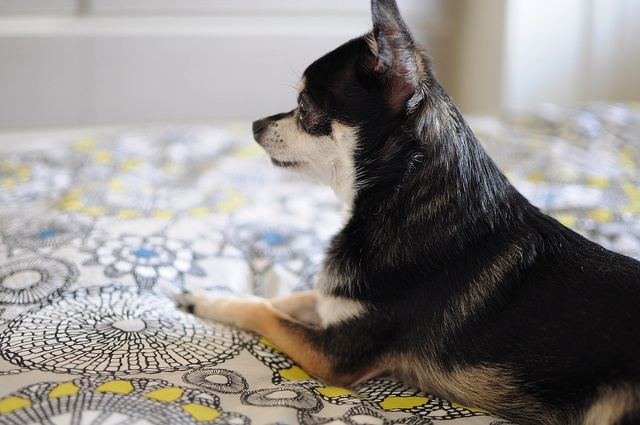Describe the objects in this image and their specific colors. I can see bed in darkgray, lightgray, beige, and gray tones and dog in darkgray, black, and gray tones in this image. 